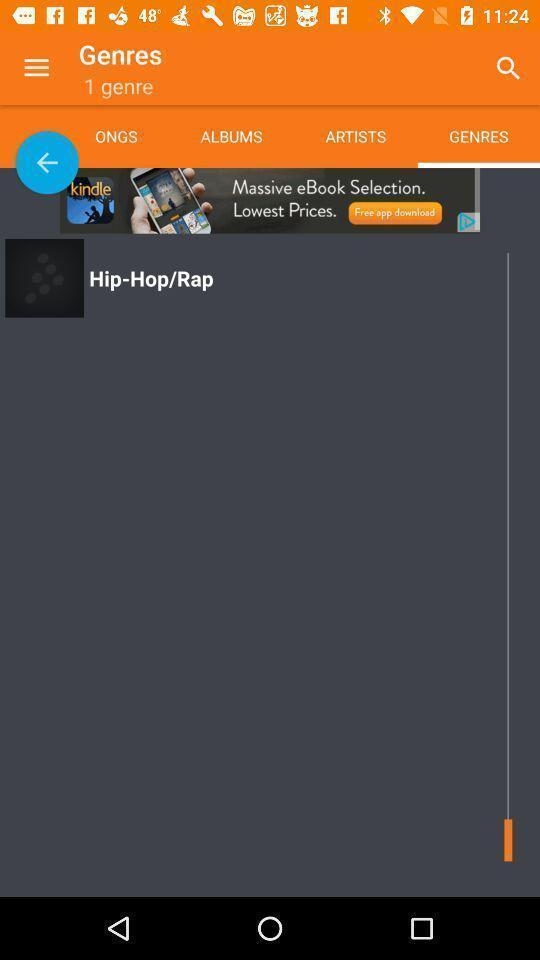What is the overall content of this screenshot? Screen displaying the genres page. 